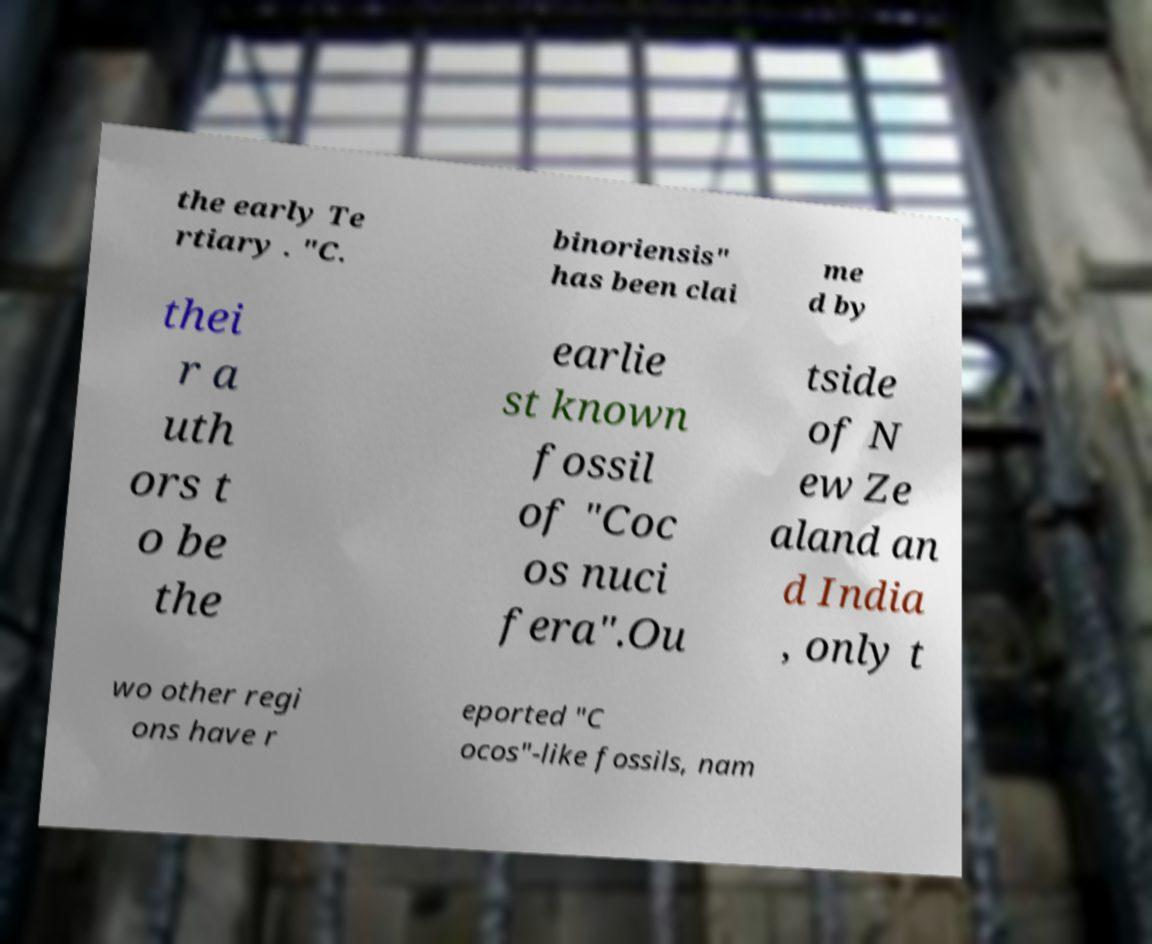What messages or text are displayed in this image? I need them in a readable, typed format. the early Te rtiary . "C. binoriensis" has been clai me d by thei r a uth ors t o be the earlie st known fossil of "Coc os nuci fera".Ou tside of N ew Ze aland an d India , only t wo other regi ons have r eported "C ocos"-like fossils, nam 